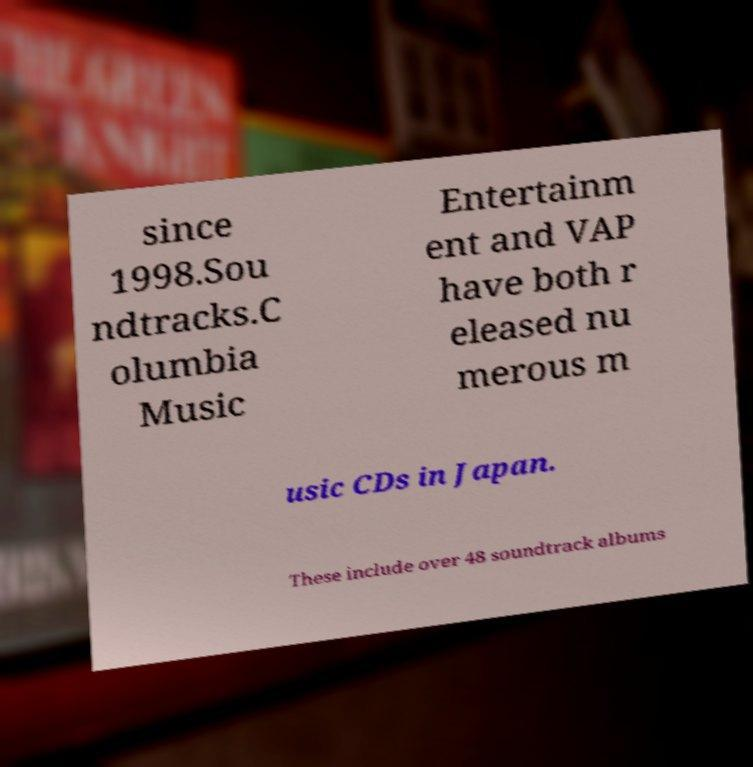Please identify and transcribe the text found in this image. since 1998.Sou ndtracks.C olumbia Music Entertainm ent and VAP have both r eleased nu merous m usic CDs in Japan. These include over 48 soundtrack albums 